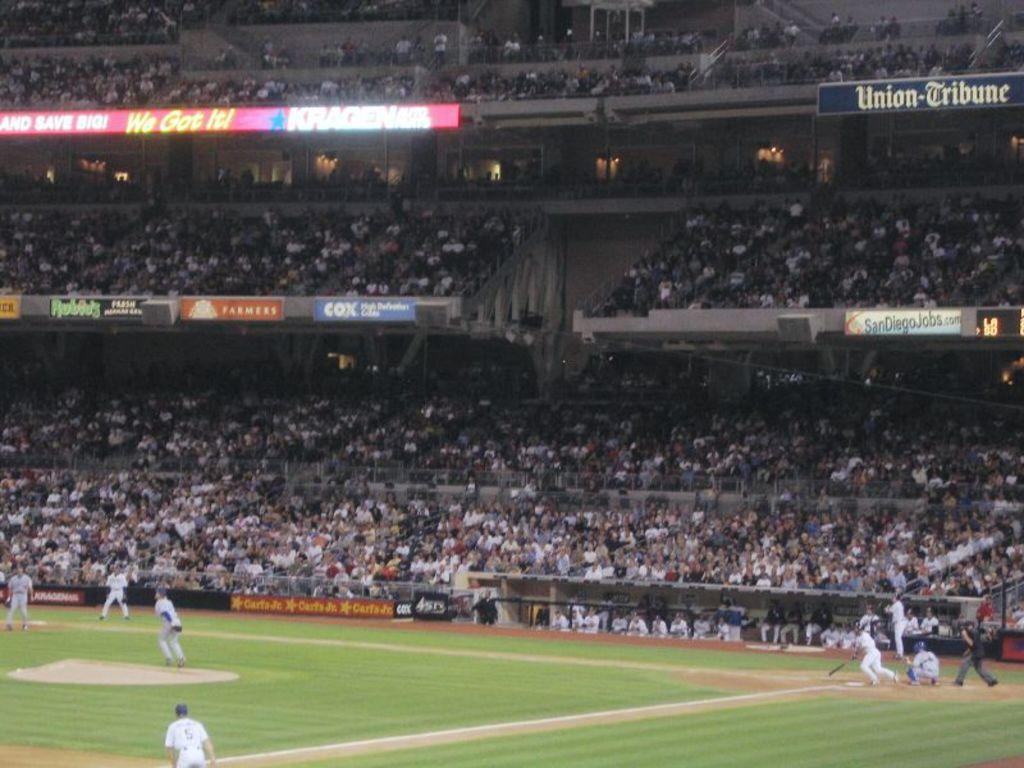What does the banner in the top right say?
Your answer should be compact. Union-tribune. What is the number of the player at third base?
Keep it short and to the point. 5. 